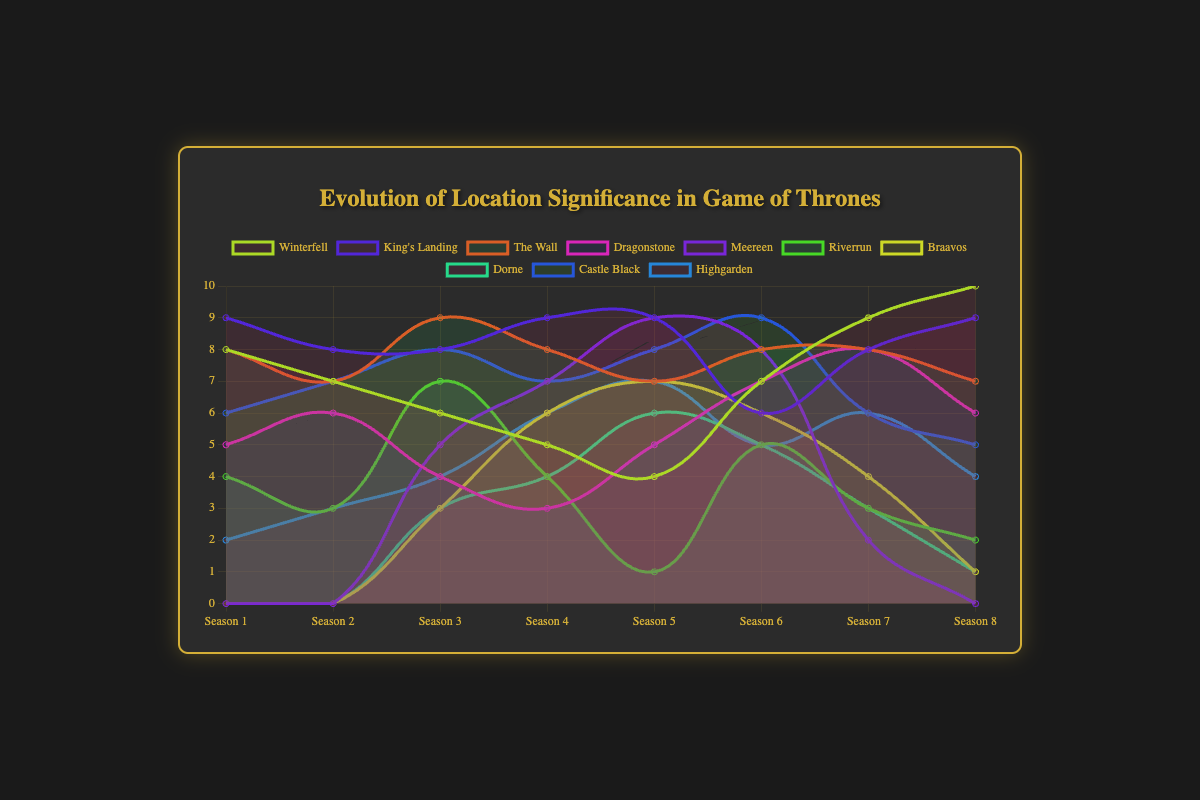Which location had the highest significance in Season 1? Observing the figure, we see that King's Landing has the highest significance with a value of 9 in Season 1.
Answer: King's Landing Which location showed the greatest increase in significance from Season 7 to Season 8? Comparing the values from Season 7 to Season 8, Winterfell's significance increased from 9 to 10, the largest increase.
Answer: Winterfell What is the total significance for Braavos across all seasons shown? Summing Braavos' significance values across all seasons: 0 + 0 + 3 + 6 + 7 + 6 + 4 + 1 = 27.
Answer: 27 How does the significance of Meereen in Season 5 compare to its significance in Season 6? Meereen's significance in Season 5 is 9, and in Season 6 it is 8. So, it decreases by 1 unit from Season 5 to Season 6.
Answer: Decreases by 1 Which location had the lowest significance in Season 8? The lowest significance in Season 8 is 0, seen in Meereen.
Answer: Meereen What is the average significance of Dorne across all seasons where it appears? The seasons where Dorne has non-zero significance are Seasons 3 to 8: (3 + 4 + 6 + 5 + 3 + 1) / 6 = 3.67.
Answer: 3.67 Which two locations had equal significance in both Season 7 and Season 8? Observing the figure, The Wall has significance 8 in both Season 7 and Season 8.
Answer: The Wall What is the difference between the highest and lowest significance values seen for King's Landing over all seasons? The highest significance for King's Landing is 9 and the lowest is 6, so the difference is 9 - 6 = 3.
Answer: 3 Between which two consecutive seasons did Castle Black experience its greatest drop in significance? Castle Black's significance drops from 9 in Season 6 to 6 in Season 7, a drop of 3 units.
Answer: Season 6 to Season 7 